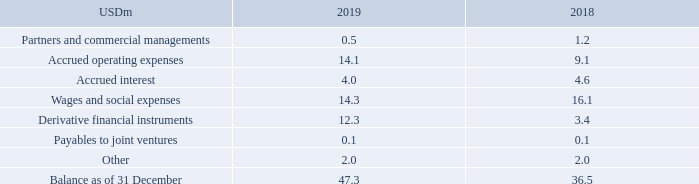NOTE 14 – OTHER LIABILITIES
The carrying amount is a reasonable approximation of fair value due to the short-term nature of the receivables. Please refer to note 21 for further information on fair value hierarchies.
Why is the carrying amount a reasonable approximation of fair value? Due to the short-term nature of the receivables. What information does note 21 contain? Further information on fair value hierarchies. In which years were the amounts of Other Liabilities calculated for? 2019, 2018. In which year was the amount under Partners and commercial managements larger? 1.2>0.5
Answer: 2018. What was the change in the Balance as of 31 December from 2018 to 2019?
Answer scale should be: million. 47.3-36.5
Answer: 10.8. What was the percentage change in the Balance as of 31 December from 2018 to 2019?
Answer scale should be: percent. (47.3-36.5)/36.5
Answer: 29.59. 